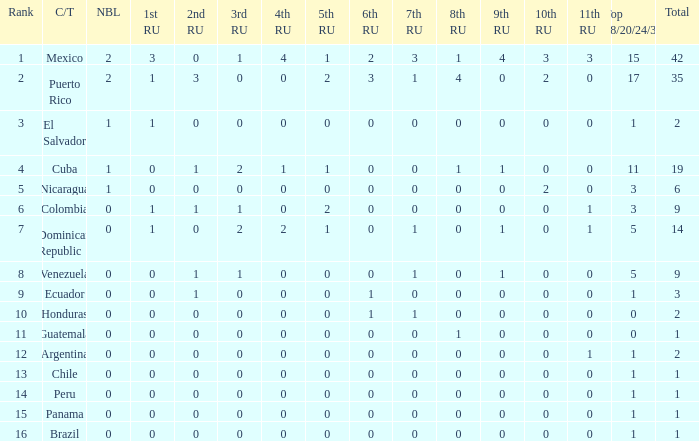What is the 7th runner-up of the country with a 10th runner-up greater than 0, a 9th runner-up greater than 0, and an 8th runner-up greater than 1? None. 